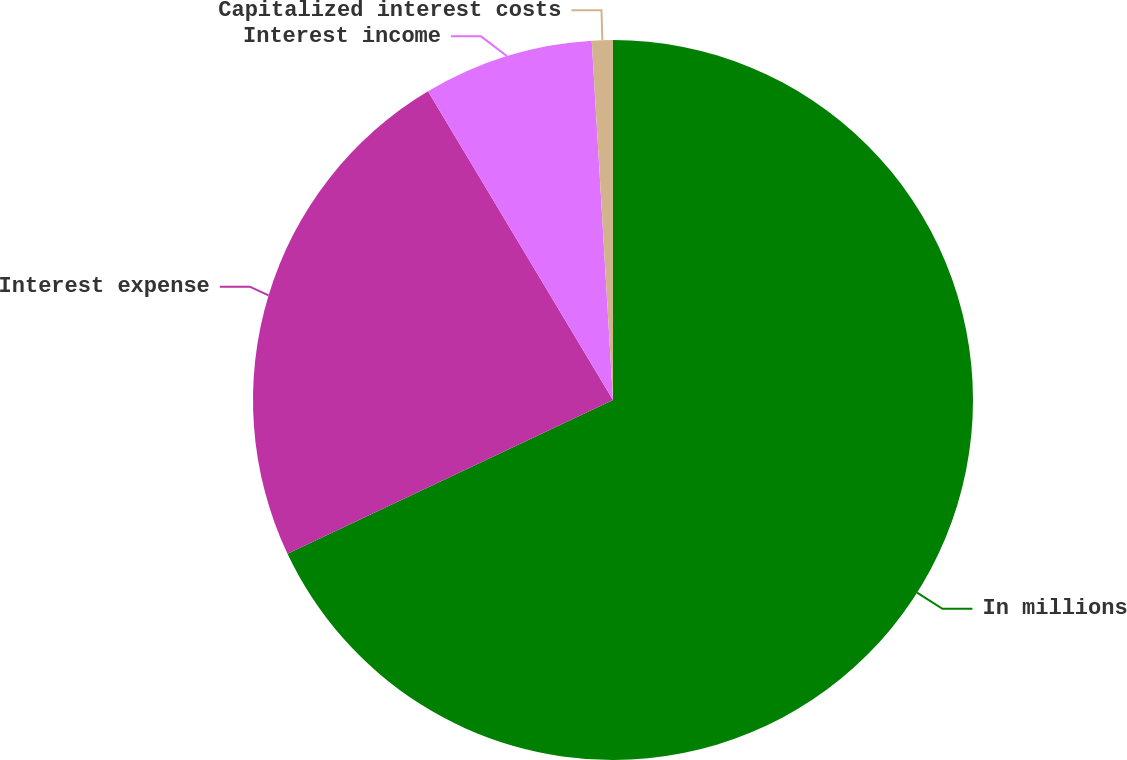Convert chart. <chart><loc_0><loc_0><loc_500><loc_500><pie_chart><fcel>In millions<fcel>Interest expense<fcel>Interest income<fcel>Capitalized interest costs<nl><fcel>67.97%<fcel>23.43%<fcel>7.65%<fcel>0.94%<nl></chart> 